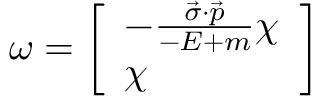Convert formula to latex. <formula><loc_0><loc_0><loc_500><loc_500>\omega = { \left [ \begin{array} { l } { - { \frac { { \vec { \sigma } } \cdot { \vec { p } } } { - E + m } } \chi } \\ { \chi } \end{array} \right ] }</formula> 